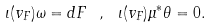Convert formula to latex. <formula><loc_0><loc_0><loc_500><loc_500>\iota ( v _ { F } ) \omega = d F \ , \ \iota ( v _ { F } ) \mu ^ { * } \theta = 0 .</formula> 